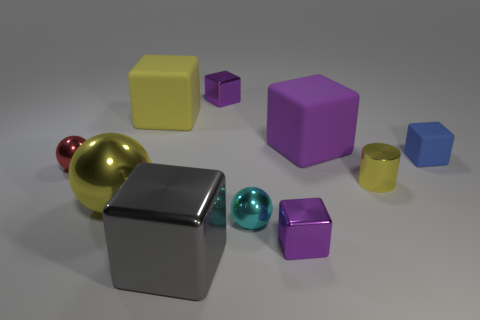Subtract all yellow cylinders. How many purple blocks are left? 3 Subtract all yellow cubes. How many cubes are left? 5 Subtract 4 cubes. How many cubes are left? 2 Subtract all tiny metallic cubes. How many cubes are left? 4 Subtract all red blocks. Subtract all brown balls. How many blocks are left? 6 Subtract all spheres. How many objects are left? 7 Subtract all large gray matte things. Subtract all tiny red metallic objects. How many objects are left? 9 Add 5 blue cubes. How many blue cubes are left? 6 Add 7 small purple things. How many small purple things exist? 9 Subtract 0 blue balls. How many objects are left? 10 